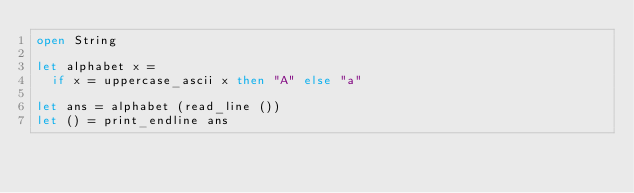Convert code to text. <code><loc_0><loc_0><loc_500><loc_500><_OCaml_>open String

let alphabet x =
  if x = uppercase_ascii x then "A" else "a"

let ans = alphabet (read_line ())
let () = print_endline ans
</code> 